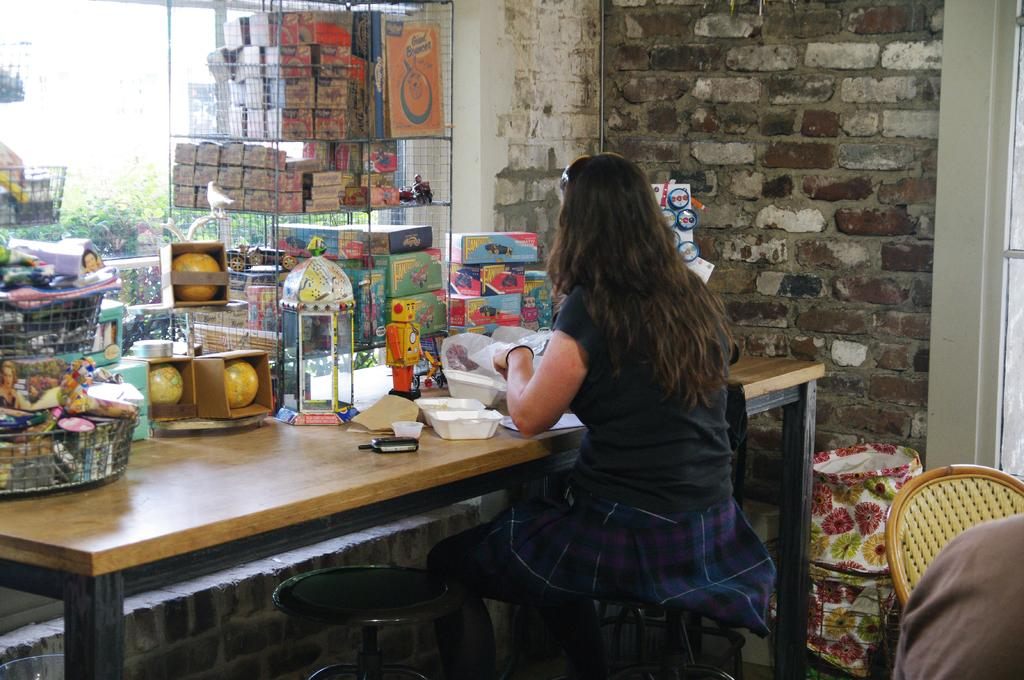What type of furniture is present in the image? There is a table in the image. What is placed on the table? There are toys on the table. Can you describe the woman's position in the image? The woman is seated on a chair in the image. What hobbies does the woman have, as indicated by the toys on the table? There is no information about the woman's hobbies in the image, and the toys on the table do not necessarily indicate her hobbies. How many toes can be seen on the woman's feet in the image? The image does not show the woman's feet, so the number of toes cannot be determined. 